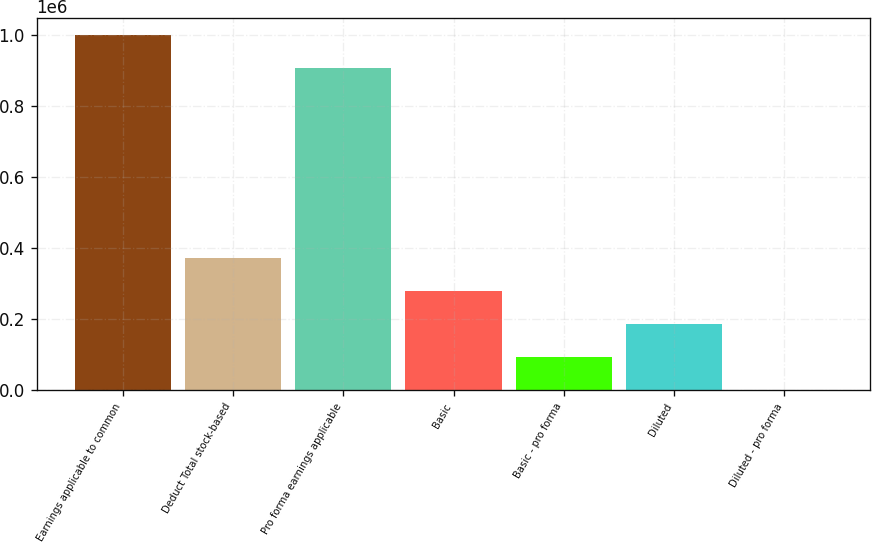Convert chart. <chart><loc_0><loc_0><loc_500><loc_500><bar_chart><fcel>Earnings applicable to common<fcel>Deduct Total stock-based<fcel>Pro forma earnings applicable<fcel>Basic<fcel>Basic - pro forma<fcel>Diluted<fcel>Diluted - pro forma<nl><fcel>997937<fcel>370780<fcel>905243<fcel>278086<fcel>92697.8<fcel>185392<fcel>3.92<nl></chart> 